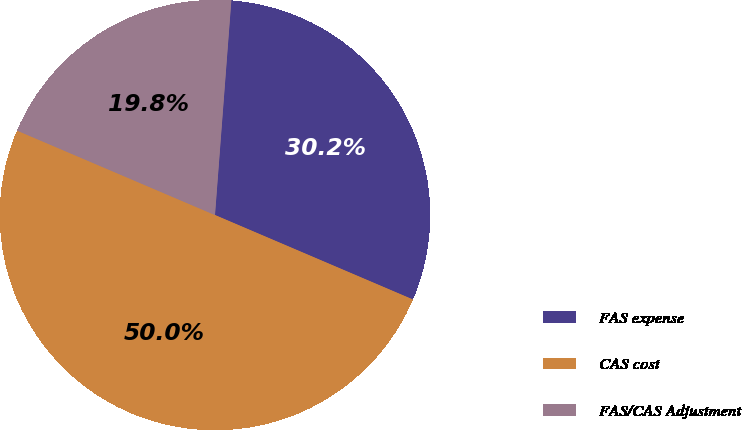Convert chart to OTSL. <chart><loc_0><loc_0><loc_500><loc_500><pie_chart><fcel>FAS expense<fcel>CAS cost<fcel>FAS/CAS Adjustment<nl><fcel>30.21%<fcel>50.0%<fcel>19.79%<nl></chart> 